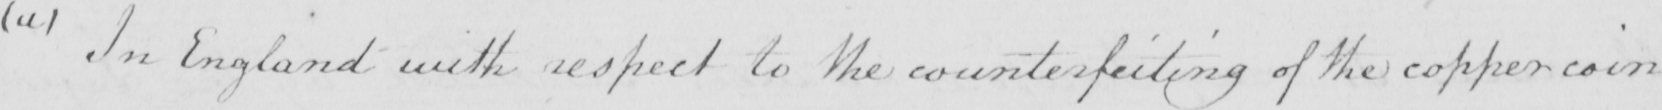Transcribe the text shown in this historical manuscript line. ( a )  In England with respect to the counterfeiting of the copper coin 